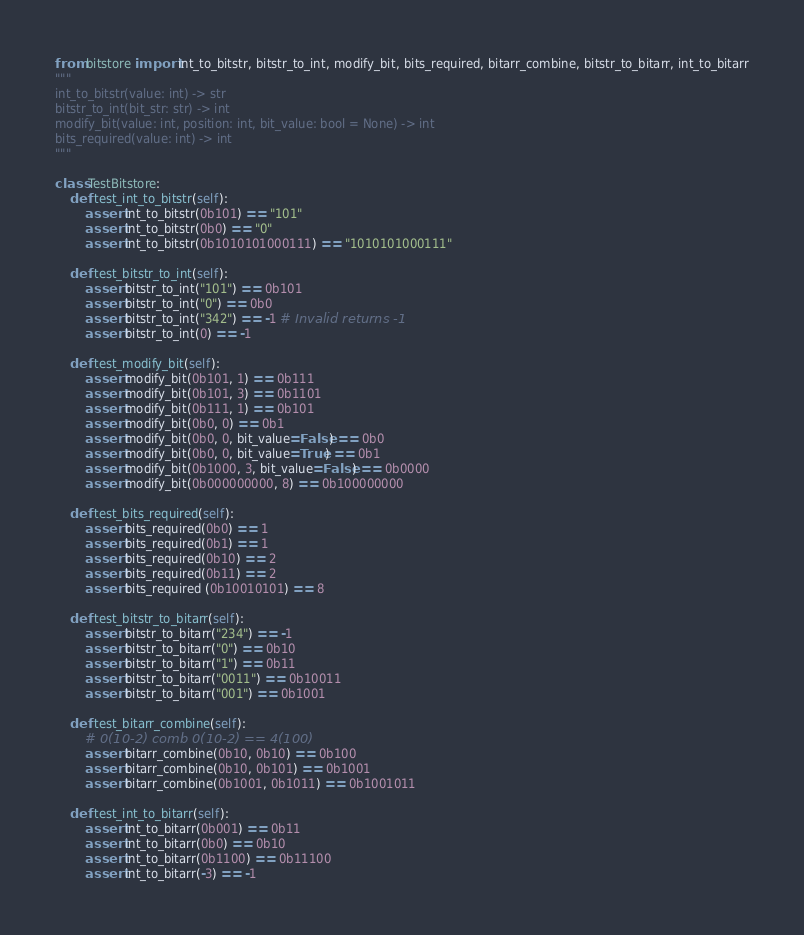Convert code to text. <code><loc_0><loc_0><loc_500><loc_500><_Python_>from bitstore import int_to_bitstr, bitstr_to_int, modify_bit, bits_required, bitarr_combine, bitstr_to_bitarr, int_to_bitarr
"""
int_to_bitstr(value: int) -> str
bitstr_to_int(bit_str: str) -> int
modify_bit(value: int, position: int, bit_value: bool = None) -> int
bits_required(value: int) -> int
"""

class TestBitstore:
    def test_int_to_bitstr(self):
        assert int_to_bitstr(0b101) == "101"
        assert int_to_bitstr(0b0) == "0"
        assert int_to_bitstr(0b1010101000111) == "1010101000111"

    def test_bitstr_to_int(self):
        assert bitstr_to_int("101") == 0b101
        assert bitstr_to_int("0") == 0b0
        assert bitstr_to_int("342") == -1 # Invalid returns -1
        assert bitstr_to_int(0) == -1

    def test_modify_bit(self):
        assert modify_bit(0b101, 1) == 0b111
        assert modify_bit(0b101, 3) == 0b1101
        assert modify_bit(0b111, 1) == 0b101
        assert modify_bit(0b0, 0) == 0b1
        assert modify_bit(0b0, 0, bit_value=False) == 0b0
        assert modify_bit(0b0, 0, bit_value=True) == 0b1
        assert modify_bit(0b1000, 3, bit_value=False) == 0b0000
        assert modify_bit(0b000000000, 8) == 0b100000000

    def test_bits_required(self):
        assert bits_required(0b0) == 1
        assert bits_required(0b1) == 1
        assert bits_required(0b10) == 2
        assert bits_required(0b11) == 2
        assert bits_required (0b10010101) == 8

    def test_bitstr_to_bitarr(self):
        assert bitstr_to_bitarr("234") == -1
        assert bitstr_to_bitarr("0") == 0b10
        assert bitstr_to_bitarr("1") == 0b11
        assert bitstr_to_bitarr("0011") == 0b10011
        assert bitstr_to_bitarr("001") == 0b1001

    def test_bitarr_combine(self):
        # 0(10-2) comb 0(10-2) == 4(100)
        assert bitarr_combine(0b10, 0b10) == 0b100
        assert bitarr_combine(0b10, 0b101) == 0b1001
        assert bitarr_combine(0b1001, 0b1011) == 0b1001011
    
    def test_int_to_bitarr(self):
        assert int_to_bitarr(0b001) == 0b11
        assert int_to_bitarr(0b0) == 0b10
        assert int_to_bitarr(0b1100) == 0b11100
        assert int_to_bitarr(-3) == -1</code> 